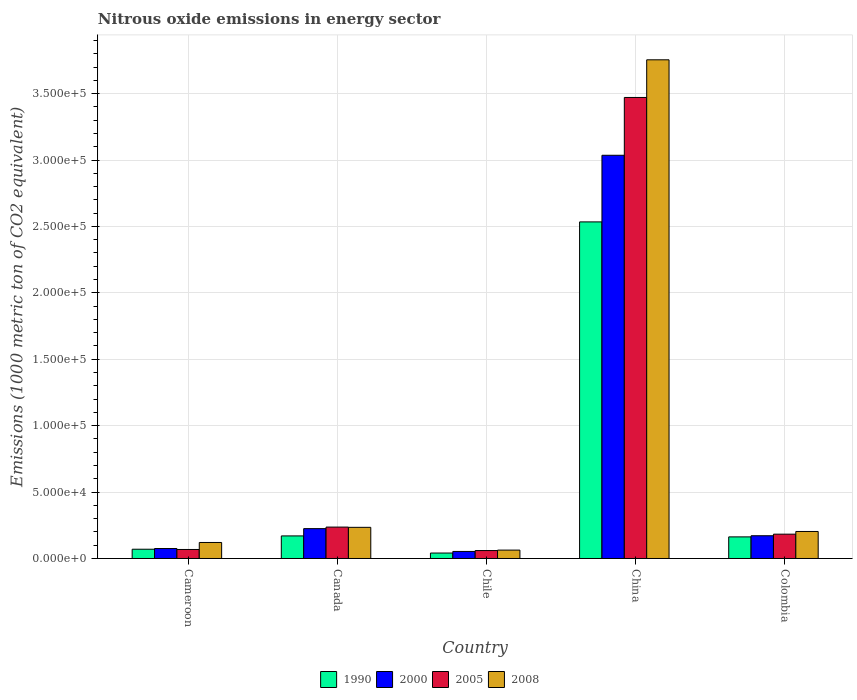How many different coloured bars are there?
Your answer should be very brief. 4. How many bars are there on the 2nd tick from the left?
Provide a succinct answer. 4. In how many cases, is the number of bars for a given country not equal to the number of legend labels?
Make the answer very short. 0. What is the amount of nitrous oxide emitted in 2008 in Cameroon?
Keep it short and to the point. 1.21e+04. Across all countries, what is the maximum amount of nitrous oxide emitted in 1990?
Your response must be concise. 2.53e+05. Across all countries, what is the minimum amount of nitrous oxide emitted in 1990?
Give a very brief answer. 4097. In which country was the amount of nitrous oxide emitted in 2005 maximum?
Ensure brevity in your answer.  China. In which country was the amount of nitrous oxide emitted in 2005 minimum?
Ensure brevity in your answer.  Chile. What is the total amount of nitrous oxide emitted in 1990 in the graph?
Ensure brevity in your answer.  2.98e+05. What is the difference between the amount of nitrous oxide emitted in 2005 in Cameroon and that in Canada?
Offer a very short reply. -1.69e+04. What is the difference between the amount of nitrous oxide emitted in 2005 in Chile and the amount of nitrous oxide emitted in 2008 in China?
Make the answer very short. -3.69e+05. What is the average amount of nitrous oxide emitted in 2008 per country?
Your response must be concise. 8.75e+04. What is the difference between the amount of nitrous oxide emitted of/in 2005 and amount of nitrous oxide emitted of/in 2000 in China?
Your response must be concise. 4.35e+04. In how many countries, is the amount of nitrous oxide emitted in 1990 greater than 140000 1000 metric ton?
Ensure brevity in your answer.  1. What is the ratio of the amount of nitrous oxide emitted in 1990 in China to that in Colombia?
Provide a succinct answer. 15.58. Is the amount of nitrous oxide emitted in 2005 in Chile less than that in Colombia?
Offer a very short reply. Yes. What is the difference between the highest and the second highest amount of nitrous oxide emitted in 1990?
Offer a very short reply. 2.37e+05. What is the difference between the highest and the lowest amount of nitrous oxide emitted in 2008?
Your response must be concise. 3.69e+05. In how many countries, is the amount of nitrous oxide emitted in 2000 greater than the average amount of nitrous oxide emitted in 2000 taken over all countries?
Offer a terse response. 1. What does the 3rd bar from the left in Chile represents?
Ensure brevity in your answer.  2005. Is it the case that in every country, the sum of the amount of nitrous oxide emitted in 2000 and amount of nitrous oxide emitted in 2005 is greater than the amount of nitrous oxide emitted in 1990?
Ensure brevity in your answer.  Yes. Are all the bars in the graph horizontal?
Offer a very short reply. No. What is the difference between two consecutive major ticks on the Y-axis?
Keep it short and to the point. 5.00e+04. Does the graph contain any zero values?
Your response must be concise. No. Does the graph contain grids?
Provide a succinct answer. Yes. How many legend labels are there?
Your answer should be compact. 4. How are the legend labels stacked?
Keep it short and to the point. Horizontal. What is the title of the graph?
Provide a short and direct response. Nitrous oxide emissions in energy sector. What is the label or title of the Y-axis?
Provide a short and direct response. Emissions (1000 metric ton of CO2 equivalent). What is the Emissions (1000 metric ton of CO2 equivalent) of 1990 in Cameroon?
Offer a very short reply. 6970.1. What is the Emissions (1000 metric ton of CO2 equivalent) of 2000 in Cameroon?
Provide a succinct answer. 7501.6. What is the Emissions (1000 metric ton of CO2 equivalent) in 2005 in Cameroon?
Give a very brief answer. 6781.9. What is the Emissions (1000 metric ton of CO2 equivalent) in 2008 in Cameroon?
Your response must be concise. 1.21e+04. What is the Emissions (1000 metric ton of CO2 equivalent) in 1990 in Canada?
Keep it short and to the point. 1.70e+04. What is the Emissions (1000 metric ton of CO2 equivalent) in 2000 in Canada?
Your response must be concise. 2.25e+04. What is the Emissions (1000 metric ton of CO2 equivalent) in 2005 in Canada?
Keep it short and to the point. 2.36e+04. What is the Emissions (1000 metric ton of CO2 equivalent) in 2008 in Canada?
Your answer should be compact. 2.34e+04. What is the Emissions (1000 metric ton of CO2 equivalent) of 1990 in Chile?
Your answer should be compact. 4097. What is the Emissions (1000 metric ton of CO2 equivalent) in 2000 in Chile?
Your answer should be very brief. 5305.7. What is the Emissions (1000 metric ton of CO2 equivalent) in 2005 in Chile?
Keep it short and to the point. 5967.8. What is the Emissions (1000 metric ton of CO2 equivalent) in 2008 in Chile?
Ensure brevity in your answer.  6312. What is the Emissions (1000 metric ton of CO2 equivalent) of 1990 in China?
Keep it short and to the point. 2.53e+05. What is the Emissions (1000 metric ton of CO2 equivalent) of 2000 in China?
Make the answer very short. 3.04e+05. What is the Emissions (1000 metric ton of CO2 equivalent) of 2005 in China?
Provide a succinct answer. 3.47e+05. What is the Emissions (1000 metric ton of CO2 equivalent) of 2008 in China?
Offer a very short reply. 3.75e+05. What is the Emissions (1000 metric ton of CO2 equivalent) of 1990 in Colombia?
Make the answer very short. 1.63e+04. What is the Emissions (1000 metric ton of CO2 equivalent) of 2000 in Colombia?
Make the answer very short. 1.71e+04. What is the Emissions (1000 metric ton of CO2 equivalent) of 2005 in Colombia?
Keep it short and to the point. 1.83e+04. What is the Emissions (1000 metric ton of CO2 equivalent) of 2008 in Colombia?
Your response must be concise. 2.03e+04. Across all countries, what is the maximum Emissions (1000 metric ton of CO2 equivalent) in 1990?
Offer a very short reply. 2.53e+05. Across all countries, what is the maximum Emissions (1000 metric ton of CO2 equivalent) of 2000?
Make the answer very short. 3.04e+05. Across all countries, what is the maximum Emissions (1000 metric ton of CO2 equivalent) of 2005?
Ensure brevity in your answer.  3.47e+05. Across all countries, what is the maximum Emissions (1000 metric ton of CO2 equivalent) in 2008?
Provide a short and direct response. 3.75e+05. Across all countries, what is the minimum Emissions (1000 metric ton of CO2 equivalent) in 1990?
Provide a succinct answer. 4097. Across all countries, what is the minimum Emissions (1000 metric ton of CO2 equivalent) of 2000?
Provide a succinct answer. 5305.7. Across all countries, what is the minimum Emissions (1000 metric ton of CO2 equivalent) in 2005?
Your answer should be very brief. 5967.8. Across all countries, what is the minimum Emissions (1000 metric ton of CO2 equivalent) of 2008?
Make the answer very short. 6312. What is the total Emissions (1000 metric ton of CO2 equivalent) in 1990 in the graph?
Make the answer very short. 2.98e+05. What is the total Emissions (1000 metric ton of CO2 equivalent) in 2000 in the graph?
Your response must be concise. 3.56e+05. What is the total Emissions (1000 metric ton of CO2 equivalent) of 2005 in the graph?
Your answer should be compact. 4.02e+05. What is the total Emissions (1000 metric ton of CO2 equivalent) in 2008 in the graph?
Give a very brief answer. 4.38e+05. What is the difference between the Emissions (1000 metric ton of CO2 equivalent) in 1990 in Cameroon and that in Canada?
Keep it short and to the point. -1.00e+04. What is the difference between the Emissions (1000 metric ton of CO2 equivalent) of 2000 in Cameroon and that in Canada?
Ensure brevity in your answer.  -1.50e+04. What is the difference between the Emissions (1000 metric ton of CO2 equivalent) in 2005 in Cameroon and that in Canada?
Offer a terse response. -1.69e+04. What is the difference between the Emissions (1000 metric ton of CO2 equivalent) of 2008 in Cameroon and that in Canada?
Offer a very short reply. -1.14e+04. What is the difference between the Emissions (1000 metric ton of CO2 equivalent) of 1990 in Cameroon and that in Chile?
Provide a succinct answer. 2873.1. What is the difference between the Emissions (1000 metric ton of CO2 equivalent) in 2000 in Cameroon and that in Chile?
Your answer should be very brief. 2195.9. What is the difference between the Emissions (1000 metric ton of CO2 equivalent) of 2005 in Cameroon and that in Chile?
Keep it short and to the point. 814.1. What is the difference between the Emissions (1000 metric ton of CO2 equivalent) in 2008 in Cameroon and that in Chile?
Offer a very short reply. 5740.9. What is the difference between the Emissions (1000 metric ton of CO2 equivalent) of 1990 in Cameroon and that in China?
Keep it short and to the point. -2.46e+05. What is the difference between the Emissions (1000 metric ton of CO2 equivalent) in 2000 in Cameroon and that in China?
Your answer should be compact. -2.96e+05. What is the difference between the Emissions (1000 metric ton of CO2 equivalent) of 2005 in Cameroon and that in China?
Provide a succinct answer. -3.40e+05. What is the difference between the Emissions (1000 metric ton of CO2 equivalent) in 2008 in Cameroon and that in China?
Your response must be concise. -3.63e+05. What is the difference between the Emissions (1000 metric ton of CO2 equivalent) of 1990 in Cameroon and that in Colombia?
Provide a succinct answer. -9292. What is the difference between the Emissions (1000 metric ton of CO2 equivalent) in 2000 in Cameroon and that in Colombia?
Ensure brevity in your answer.  -9624.9. What is the difference between the Emissions (1000 metric ton of CO2 equivalent) in 2005 in Cameroon and that in Colombia?
Offer a terse response. -1.15e+04. What is the difference between the Emissions (1000 metric ton of CO2 equivalent) in 2008 in Cameroon and that in Colombia?
Make the answer very short. -8286.7. What is the difference between the Emissions (1000 metric ton of CO2 equivalent) in 1990 in Canada and that in Chile?
Provide a succinct answer. 1.29e+04. What is the difference between the Emissions (1000 metric ton of CO2 equivalent) of 2000 in Canada and that in Chile?
Offer a very short reply. 1.72e+04. What is the difference between the Emissions (1000 metric ton of CO2 equivalent) of 2005 in Canada and that in Chile?
Ensure brevity in your answer.  1.77e+04. What is the difference between the Emissions (1000 metric ton of CO2 equivalent) in 2008 in Canada and that in Chile?
Your response must be concise. 1.71e+04. What is the difference between the Emissions (1000 metric ton of CO2 equivalent) of 1990 in Canada and that in China?
Offer a very short reply. -2.36e+05. What is the difference between the Emissions (1000 metric ton of CO2 equivalent) in 2000 in Canada and that in China?
Your response must be concise. -2.81e+05. What is the difference between the Emissions (1000 metric ton of CO2 equivalent) in 2005 in Canada and that in China?
Offer a terse response. -3.23e+05. What is the difference between the Emissions (1000 metric ton of CO2 equivalent) in 2008 in Canada and that in China?
Your answer should be very brief. -3.52e+05. What is the difference between the Emissions (1000 metric ton of CO2 equivalent) of 1990 in Canada and that in Colombia?
Your answer should be very brief. 737.3. What is the difference between the Emissions (1000 metric ton of CO2 equivalent) in 2000 in Canada and that in Colombia?
Provide a short and direct response. 5354.3. What is the difference between the Emissions (1000 metric ton of CO2 equivalent) of 2005 in Canada and that in Colombia?
Offer a very short reply. 5332.3. What is the difference between the Emissions (1000 metric ton of CO2 equivalent) in 2008 in Canada and that in Colombia?
Make the answer very short. 3108.7. What is the difference between the Emissions (1000 metric ton of CO2 equivalent) in 1990 in Chile and that in China?
Make the answer very short. -2.49e+05. What is the difference between the Emissions (1000 metric ton of CO2 equivalent) of 2000 in Chile and that in China?
Provide a short and direct response. -2.98e+05. What is the difference between the Emissions (1000 metric ton of CO2 equivalent) in 2005 in Chile and that in China?
Ensure brevity in your answer.  -3.41e+05. What is the difference between the Emissions (1000 metric ton of CO2 equivalent) of 2008 in Chile and that in China?
Give a very brief answer. -3.69e+05. What is the difference between the Emissions (1000 metric ton of CO2 equivalent) of 1990 in Chile and that in Colombia?
Offer a terse response. -1.22e+04. What is the difference between the Emissions (1000 metric ton of CO2 equivalent) in 2000 in Chile and that in Colombia?
Give a very brief answer. -1.18e+04. What is the difference between the Emissions (1000 metric ton of CO2 equivalent) of 2005 in Chile and that in Colombia?
Give a very brief answer. -1.23e+04. What is the difference between the Emissions (1000 metric ton of CO2 equivalent) of 2008 in Chile and that in Colombia?
Your answer should be very brief. -1.40e+04. What is the difference between the Emissions (1000 metric ton of CO2 equivalent) in 1990 in China and that in Colombia?
Your response must be concise. 2.37e+05. What is the difference between the Emissions (1000 metric ton of CO2 equivalent) in 2000 in China and that in Colombia?
Your response must be concise. 2.86e+05. What is the difference between the Emissions (1000 metric ton of CO2 equivalent) in 2005 in China and that in Colombia?
Give a very brief answer. 3.29e+05. What is the difference between the Emissions (1000 metric ton of CO2 equivalent) of 2008 in China and that in Colombia?
Keep it short and to the point. 3.55e+05. What is the difference between the Emissions (1000 metric ton of CO2 equivalent) of 1990 in Cameroon and the Emissions (1000 metric ton of CO2 equivalent) of 2000 in Canada?
Keep it short and to the point. -1.55e+04. What is the difference between the Emissions (1000 metric ton of CO2 equivalent) of 1990 in Cameroon and the Emissions (1000 metric ton of CO2 equivalent) of 2005 in Canada?
Your answer should be compact. -1.67e+04. What is the difference between the Emissions (1000 metric ton of CO2 equivalent) in 1990 in Cameroon and the Emissions (1000 metric ton of CO2 equivalent) in 2008 in Canada?
Offer a very short reply. -1.65e+04. What is the difference between the Emissions (1000 metric ton of CO2 equivalent) in 2000 in Cameroon and the Emissions (1000 metric ton of CO2 equivalent) in 2005 in Canada?
Ensure brevity in your answer.  -1.61e+04. What is the difference between the Emissions (1000 metric ton of CO2 equivalent) of 2000 in Cameroon and the Emissions (1000 metric ton of CO2 equivalent) of 2008 in Canada?
Keep it short and to the point. -1.59e+04. What is the difference between the Emissions (1000 metric ton of CO2 equivalent) of 2005 in Cameroon and the Emissions (1000 metric ton of CO2 equivalent) of 2008 in Canada?
Provide a short and direct response. -1.67e+04. What is the difference between the Emissions (1000 metric ton of CO2 equivalent) of 1990 in Cameroon and the Emissions (1000 metric ton of CO2 equivalent) of 2000 in Chile?
Provide a short and direct response. 1664.4. What is the difference between the Emissions (1000 metric ton of CO2 equivalent) in 1990 in Cameroon and the Emissions (1000 metric ton of CO2 equivalent) in 2005 in Chile?
Ensure brevity in your answer.  1002.3. What is the difference between the Emissions (1000 metric ton of CO2 equivalent) of 1990 in Cameroon and the Emissions (1000 metric ton of CO2 equivalent) of 2008 in Chile?
Offer a very short reply. 658.1. What is the difference between the Emissions (1000 metric ton of CO2 equivalent) of 2000 in Cameroon and the Emissions (1000 metric ton of CO2 equivalent) of 2005 in Chile?
Give a very brief answer. 1533.8. What is the difference between the Emissions (1000 metric ton of CO2 equivalent) of 2000 in Cameroon and the Emissions (1000 metric ton of CO2 equivalent) of 2008 in Chile?
Make the answer very short. 1189.6. What is the difference between the Emissions (1000 metric ton of CO2 equivalent) in 2005 in Cameroon and the Emissions (1000 metric ton of CO2 equivalent) in 2008 in Chile?
Keep it short and to the point. 469.9. What is the difference between the Emissions (1000 metric ton of CO2 equivalent) of 1990 in Cameroon and the Emissions (1000 metric ton of CO2 equivalent) of 2000 in China?
Offer a very short reply. -2.97e+05. What is the difference between the Emissions (1000 metric ton of CO2 equivalent) in 1990 in Cameroon and the Emissions (1000 metric ton of CO2 equivalent) in 2005 in China?
Provide a succinct answer. -3.40e+05. What is the difference between the Emissions (1000 metric ton of CO2 equivalent) in 1990 in Cameroon and the Emissions (1000 metric ton of CO2 equivalent) in 2008 in China?
Give a very brief answer. -3.68e+05. What is the difference between the Emissions (1000 metric ton of CO2 equivalent) in 2000 in Cameroon and the Emissions (1000 metric ton of CO2 equivalent) in 2005 in China?
Give a very brief answer. -3.40e+05. What is the difference between the Emissions (1000 metric ton of CO2 equivalent) of 2000 in Cameroon and the Emissions (1000 metric ton of CO2 equivalent) of 2008 in China?
Give a very brief answer. -3.68e+05. What is the difference between the Emissions (1000 metric ton of CO2 equivalent) of 2005 in Cameroon and the Emissions (1000 metric ton of CO2 equivalent) of 2008 in China?
Provide a short and direct response. -3.69e+05. What is the difference between the Emissions (1000 metric ton of CO2 equivalent) in 1990 in Cameroon and the Emissions (1000 metric ton of CO2 equivalent) in 2000 in Colombia?
Your answer should be compact. -1.02e+04. What is the difference between the Emissions (1000 metric ton of CO2 equivalent) of 1990 in Cameroon and the Emissions (1000 metric ton of CO2 equivalent) of 2005 in Colombia?
Provide a short and direct response. -1.13e+04. What is the difference between the Emissions (1000 metric ton of CO2 equivalent) in 1990 in Cameroon and the Emissions (1000 metric ton of CO2 equivalent) in 2008 in Colombia?
Offer a terse response. -1.34e+04. What is the difference between the Emissions (1000 metric ton of CO2 equivalent) in 2000 in Cameroon and the Emissions (1000 metric ton of CO2 equivalent) in 2005 in Colombia?
Provide a succinct answer. -1.08e+04. What is the difference between the Emissions (1000 metric ton of CO2 equivalent) in 2000 in Cameroon and the Emissions (1000 metric ton of CO2 equivalent) in 2008 in Colombia?
Your response must be concise. -1.28e+04. What is the difference between the Emissions (1000 metric ton of CO2 equivalent) of 2005 in Cameroon and the Emissions (1000 metric ton of CO2 equivalent) of 2008 in Colombia?
Your response must be concise. -1.36e+04. What is the difference between the Emissions (1000 metric ton of CO2 equivalent) in 1990 in Canada and the Emissions (1000 metric ton of CO2 equivalent) in 2000 in Chile?
Keep it short and to the point. 1.17e+04. What is the difference between the Emissions (1000 metric ton of CO2 equivalent) of 1990 in Canada and the Emissions (1000 metric ton of CO2 equivalent) of 2005 in Chile?
Ensure brevity in your answer.  1.10e+04. What is the difference between the Emissions (1000 metric ton of CO2 equivalent) of 1990 in Canada and the Emissions (1000 metric ton of CO2 equivalent) of 2008 in Chile?
Make the answer very short. 1.07e+04. What is the difference between the Emissions (1000 metric ton of CO2 equivalent) of 2000 in Canada and the Emissions (1000 metric ton of CO2 equivalent) of 2005 in Chile?
Give a very brief answer. 1.65e+04. What is the difference between the Emissions (1000 metric ton of CO2 equivalent) of 2000 in Canada and the Emissions (1000 metric ton of CO2 equivalent) of 2008 in Chile?
Your answer should be compact. 1.62e+04. What is the difference between the Emissions (1000 metric ton of CO2 equivalent) of 2005 in Canada and the Emissions (1000 metric ton of CO2 equivalent) of 2008 in Chile?
Keep it short and to the point. 1.73e+04. What is the difference between the Emissions (1000 metric ton of CO2 equivalent) in 1990 in Canada and the Emissions (1000 metric ton of CO2 equivalent) in 2000 in China?
Your answer should be compact. -2.87e+05. What is the difference between the Emissions (1000 metric ton of CO2 equivalent) in 1990 in Canada and the Emissions (1000 metric ton of CO2 equivalent) in 2005 in China?
Offer a terse response. -3.30e+05. What is the difference between the Emissions (1000 metric ton of CO2 equivalent) of 1990 in Canada and the Emissions (1000 metric ton of CO2 equivalent) of 2008 in China?
Make the answer very short. -3.58e+05. What is the difference between the Emissions (1000 metric ton of CO2 equivalent) of 2000 in Canada and the Emissions (1000 metric ton of CO2 equivalent) of 2005 in China?
Give a very brief answer. -3.25e+05. What is the difference between the Emissions (1000 metric ton of CO2 equivalent) in 2000 in Canada and the Emissions (1000 metric ton of CO2 equivalent) in 2008 in China?
Keep it short and to the point. -3.53e+05. What is the difference between the Emissions (1000 metric ton of CO2 equivalent) of 2005 in Canada and the Emissions (1000 metric ton of CO2 equivalent) of 2008 in China?
Offer a very short reply. -3.52e+05. What is the difference between the Emissions (1000 metric ton of CO2 equivalent) in 1990 in Canada and the Emissions (1000 metric ton of CO2 equivalent) in 2000 in Colombia?
Ensure brevity in your answer.  -127.1. What is the difference between the Emissions (1000 metric ton of CO2 equivalent) of 1990 in Canada and the Emissions (1000 metric ton of CO2 equivalent) of 2005 in Colombia?
Offer a terse response. -1310.3. What is the difference between the Emissions (1000 metric ton of CO2 equivalent) of 1990 in Canada and the Emissions (1000 metric ton of CO2 equivalent) of 2008 in Colombia?
Ensure brevity in your answer.  -3340.2. What is the difference between the Emissions (1000 metric ton of CO2 equivalent) in 2000 in Canada and the Emissions (1000 metric ton of CO2 equivalent) in 2005 in Colombia?
Your answer should be very brief. 4171.1. What is the difference between the Emissions (1000 metric ton of CO2 equivalent) of 2000 in Canada and the Emissions (1000 metric ton of CO2 equivalent) of 2008 in Colombia?
Offer a terse response. 2141.2. What is the difference between the Emissions (1000 metric ton of CO2 equivalent) in 2005 in Canada and the Emissions (1000 metric ton of CO2 equivalent) in 2008 in Colombia?
Keep it short and to the point. 3302.4. What is the difference between the Emissions (1000 metric ton of CO2 equivalent) in 1990 in Chile and the Emissions (1000 metric ton of CO2 equivalent) in 2000 in China?
Offer a terse response. -2.99e+05. What is the difference between the Emissions (1000 metric ton of CO2 equivalent) in 1990 in Chile and the Emissions (1000 metric ton of CO2 equivalent) in 2005 in China?
Your answer should be compact. -3.43e+05. What is the difference between the Emissions (1000 metric ton of CO2 equivalent) in 1990 in Chile and the Emissions (1000 metric ton of CO2 equivalent) in 2008 in China?
Your answer should be very brief. -3.71e+05. What is the difference between the Emissions (1000 metric ton of CO2 equivalent) in 2000 in Chile and the Emissions (1000 metric ton of CO2 equivalent) in 2005 in China?
Make the answer very short. -3.42e+05. What is the difference between the Emissions (1000 metric ton of CO2 equivalent) in 2000 in Chile and the Emissions (1000 metric ton of CO2 equivalent) in 2008 in China?
Give a very brief answer. -3.70e+05. What is the difference between the Emissions (1000 metric ton of CO2 equivalent) of 2005 in Chile and the Emissions (1000 metric ton of CO2 equivalent) of 2008 in China?
Your response must be concise. -3.69e+05. What is the difference between the Emissions (1000 metric ton of CO2 equivalent) of 1990 in Chile and the Emissions (1000 metric ton of CO2 equivalent) of 2000 in Colombia?
Your answer should be compact. -1.30e+04. What is the difference between the Emissions (1000 metric ton of CO2 equivalent) in 1990 in Chile and the Emissions (1000 metric ton of CO2 equivalent) in 2005 in Colombia?
Keep it short and to the point. -1.42e+04. What is the difference between the Emissions (1000 metric ton of CO2 equivalent) in 1990 in Chile and the Emissions (1000 metric ton of CO2 equivalent) in 2008 in Colombia?
Your answer should be very brief. -1.62e+04. What is the difference between the Emissions (1000 metric ton of CO2 equivalent) of 2000 in Chile and the Emissions (1000 metric ton of CO2 equivalent) of 2005 in Colombia?
Offer a very short reply. -1.30e+04. What is the difference between the Emissions (1000 metric ton of CO2 equivalent) of 2000 in Chile and the Emissions (1000 metric ton of CO2 equivalent) of 2008 in Colombia?
Offer a terse response. -1.50e+04. What is the difference between the Emissions (1000 metric ton of CO2 equivalent) in 2005 in Chile and the Emissions (1000 metric ton of CO2 equivalent) in 2008 in Colombia?
Provide a short and direct response. -1.44e+04. What is the difference between the Emissions (1000 metric ton of CO2 equivalent) in 1990 in China and the Emissions (1000 metric ton of CO2 equivalent) in 2000 in Colombia?
Make the answer very short. 2.36e+05. What is the difference between the Emissions (1000 metric ton of CO2 equivalent) in 1990 in China and the Emissions (1000 metric ton of CO2 equivalent) in 2005 in Colombia?
Your answer should be compact. 2.35e+05. What is the difference between the Emissions (1000 metric ton of CO2 equivalent) of 1990 in China and the Emissions (1000 metric ton of CO2 equivalent) of 2008 in Colombia?
Keep it short and to the point. 2.33e+05. What is the difference between the Emissions (1000 metric ton of CO2 equivalent) of 2000 in China and the Emissions (1000 metric ton of CO2 equivalent) of 2005 in Colombia?
Ensure brevity in your answer.  2.85e+05. What is the difference between the Emissions (1000 metric ton of CO2 equivalent) in 2000 in China and the Emissions (1000 metric ton of CO2 equivalent) in 2008 in Colombia?
Provide a succinct answer. 2.83e+05. What is the difference between the Emissions (1000 metric ton of CO2 equivalent) of 2005 in China and the Emissions (1000 metric ton of CO2 equivalent) of 2008 in Colombia?
Offer a very short reply. 3.27e+05. What is the average Emissions (1000 metric ton of CO2 equivalent) of 1990 per country?
Offer a terse response. 5.95e+04. What is the average Emissions (1000 metric ton of CO2 equivalent) of 2000 per country?
Offer a very short reply. 7.12e+04. What is the average Emissions (1000 metric ton of CO2 equivalent) in 2005 per country?
Your answer should be compact. 8.04e+04. What is the average Emissions (1000 metric ton of CO2 equivalent) in 2008 per country?
Ensure brevity in your answer.  8.75e+04. What is the difference between the Emissions (1000 metric ton of CO2 equivalent) of 1990 and Emissions (1000 metric ton of CO2 equivalent) of 2000 in Cameroon?
Your response must be concise. -531.5. What is the difference between the Emissions (1000 metric ton of CO2 equivalent) in 1990 and Emissions (1000 metric ton of CO2 equivalent) in 2005 in Cameroon?
Ensure brevity in your answer.  188.2. What is the difference between the Emissions (1000 metric ton of CO2 equivalent) in 1990 and Emissions (1000 metric ton of CO2 equivalent) in 2008 in Cameroon?
Give a very brief answer. -5082.8. What is the difference between the Emissions (1000 metric ton of CO2 equivalent) in 2000 and Emissions (1000 metric ton of CO2 equivalent) in 2005 in Cameroon?
Give a very brief answer. 719.7. What is the difference between the Emissions (1000 metric ton of CO2 equivalent) in 2000 and Emissions (1000 metric ton of CO2 equivalent) in 2008 in Cameroon?
Your answer should be compact. -4551.3. What is the difference between the Emissions (1000 metric ton of CO2 equivalent) in 2005 and Emissions (1000 metric ton of CO2 equivalent) in 2008 in Cameroon?
Your response must be concise. -5271. What is the difference between the Emissions (1000 metric ton of CO2 equivalent) in 1990 and Emissions (1000 metric ton of CO2 equivalent) in 2000 in Canada?
Offer a terse response. -5481.4. What is the difference between the Emissions (1000 metric ton of CO2 equivalent) in 1990 and Emissions (1000 metric ton of CO2 equivalent) in 2005 in Canada?
Your response must be concise. -6642.6. What is the difference between the Emissions (1000 metric ton of CO2 equivalent) in 1990 and Emissions (1000 metric ton of CO2 equivalent) in 2008 in Canada?
Give a very brief answer. -6448.9. What is the difference between the Emissions (1000 metric ton of CO2 equivalent) of 2000 and Emissions (1000 metric ton of CO2 equivalent) of 2005 in Canada?
Keep it short and to the point. -1161.2. What is the difference between the Emissions (1000 metric ton of CO2 equivalent) in 2000 and Emissions (1000 metric ton of CO2 equivalent) in 2008 in Canada?
Give a very brief answer. -967.5. What is the difference between the Emissions (1000 metric ton of CO2 equivalent) in 2005 and Emissions (1000 metric ton of CO2 equivalent) in 2008 in Canada?
Provide a short and direct response. 193.7. What is the difference between the Emissions (1000 metric ton of CO2 equivalent) of 1990 and Emissions (1000 metric ton of CO2 equivalent) of 2000 in Chile?
Provide a short and direct response. -1208.7. What is the difference between the Emissions (1000 metric ton of CO2 equivalent) of 1990 and Emissions (1000 metric ton of CO2 equivalent) of 2005 in Chile?
Provide a short and direct response. -1870.8. What is the difference between the Emissions (1000 metric ton of CO2 equivalent) in 1990 and Emissions (1000 metric ton of CO2 equivalent) in 2008 in Chile?
Provide a succinct answer. -2215. What is the difference between the Emissions (1000 metric ton of CO2 equivalent) in 2000 and Emissions (1000 metric ton of CO2 equivalent) in 2005 in Chile?
Your response must be concise. -662.1. What is the difference between the Emissions (1000 metric ton of CO2 equivalent) in 2000 and Emissions (1000 metric ton of CO2 equivalent) in 2008 in Chile?
Make the answer very short. -1006.3. What is the difference between the Emissions (1000 metric ton of CO2 equivalent) of 2005 and Emissions (1000 metric ton of CO2 equivalent) of 2008 in Chile?
Keep it short and to the point. -344.2. What is the difference between the Emissions (1000 metric ton of CO2 equivalent) in 1990 and Emissions (1000 metric ton of CO2 equivalent) in 2000 in China?
Provide a short and direct response. -5.02e+04. What is the difference between the Emissions (1000 metric ton of CO2 equivalent) in 1990 and Emissions (1000 metric ton of CO2 equivalent) in 2005 in China?
Make the answer very short. -9.37e+04. What is the difference between the Emissions (1000 metric ton of CO2 equivalent) in 1990 and Emissions (1000 metric ton of CO2 equivalent) in 2008 in China?
Your response must be concise. -1.22e+05. What is the difference between the Emissions (1000 metric ton of CO2 equivalent) of 2000 and Emissions (1000 metric ton of CO2 equivalent) of 2005 in China?
Your response must be concise. -4.35e+04. What is the difference between the Emissions (1000 metric ton of CO2 equivalent) in 2000 and Emissions (1000 metric ton of CO2 equivalent) in 2008 in China?
Provide a short and direct response. -7.19e+04. What is the difference between the Emissions (1000 metric ton of CO2 equivalent) in 2005 and Emissions (1000 metric ton of CO2 equivalent) in 2008 in China?
Offer a very short reply. -2.83e+04. What is the difference between the Emissions (1000 metric ton of CO2 equivalent) of 1990 and Emissions (1000 metric ton of CO2 equivalent) of 2000 in Colombia?
Make the answer very short. -864.4. What is the difference between the Emissions (1000 metric ton of CO2 equivalent) of 1990 and Emissions (1000 metric ton of CO2 equivalent) of 2005 in Colombia?
Keep it short and to the point. -2047.6. What is the difference between the Emissions (1000 metric ton of CO2 equivalent) in 1990 and Emissions (1000 metric ton of CO2 equivalent) in 2008 in Colombia?
Give a very brief answer. -4077.5. What is the difference between the Emissions (1000 metric ton of CO2 equivalent) of 2000 and Emissions (1000 metric ton of CO2 equivalent) of 2005 in Colombia?
Offer a terse response. -1183.2. What is the difference between the Emissions (1000 metric ton of CO2 equivalent) in 2000 and Emissions (1000 metric ton of CO2 equivalent) in 2008 in Colombia?
Offer a very short reply. -3213.1. What is the difference between the Emissions (1000 metric ton of CO2 equivalent) of 2005 and Emissions (1000 metric ton of CO2 equivalent) of 2008 in Colombia?
Give a very brief answer. -2029.9. What is the ratio of the Emissions (1000 metric ton of CO2 equivalent) of 1990 in Cameroon to that in Canada?
Your answer should be very brief. 0.41. What is the ratio of the Emissions (1000 metric ton of CO2 equivalent) of 2000 in Cameroon to that in Canada?
Your answer should be very brief. 0.33. What is the ratio of the Emissions (1000 metric ton of CO2 equivalent) of 2005 in Cameroon to that in Canada?
Your answer should be very brief. 0.29. What is the ratio of the Emissions (1000 metric ton of CO2 equivalent) of 2008 in Cameroon to that in Canada?
Offer a very short reply. 0.51. What is the ratio of the Emissions (1000 metric ton of CO2 equivalent) in 1990 in Cameroon to that in Chile?
Your answer should be very brief. 1.7. What is the ratio of the Emissions (1000 metric ton of CO2 equivalent) of 2000 in Cameroon to that in Chile?
Keep it short and to the point. 1.41. What is the ratio of the Emissions (1000 metric ton of CO2 equivalent) in 2005 in Cameroon to that in Chile?
Offer a terse response. 1.14. What is the ratio of the Emissions (1000 metric ton of CO2 equivalent) in 2008 in Cameroon to that in Chile?
Provide a succinct answer. 1.91. What is the ratio of the Emissions (1000 metric ton of CO2 equivalent) in 1990 in Cameroon to that in China?
Offer a very short reply. 0.03. What is the ratio of the Emissions (1000 metric ton of CO2 equivalent) in 2000 in Cameroon to that in China?
Offer a very short reply. 0.02. What is the ratio of the Emissions (1000 metric ton of CO2 equivalent) of 2005 in Cameroon to that in China?
Your answer should be compact. 0.02. What is the ratio of the Emissions (1000 metric ton of CO2 equivalent) of 2008 in Cameroon to that in China?
Your response must be concise. 0.03. What is the ratio of the Emissions (1000 metric ton of CO2 equivalent) in 1990 in Cameroon to that in Colombia?
Give a very brief answer. 0.43. What is the ratio of the Emissions (1000 metric ton of CO2 equivalent) of 2000 in Cameroon to that in Colombia?
Provide a short and direct response. 0.44. What is the ratio of the Emissions (1000 metric ton of CO2 equivalent) in 2005 in Cameroon to that in Colombia?
Offer a very short reply. 0.37. What is the ratio of the Emissions (1000 metric ton of CO2 equivalent) in 2008 in Cameroon to that in Colombia?
Your answer should be compact. 0.59. What is the ratio of the Emissions (1000 metric ton of CO2 equivalent) in 1990 in Canada to that in Chile?
Offer a very short reply. 4.15. What is the ratio of the Emissions (1000 metric ton of CO2 equivalent) in 2000 in Canada to that in Chile?
Offer a terse response. 4.24. What is the ratio of the Emissions (1000 metric ton of CO2 equivalent) of 2005 in Canada to that in Chile?
Your response must be concise. 3.96. What is the ratio of the Emissions (1000 metric ton of CO2 equivalent) of 2008 in Canada to that in Chile?
Offer a terse response. 3.71. What is the ratio of the Emissions (1000 metric ton of CO2 equivalent) in 1990 in Canada to that in China?
Ensure brevity in your answer.  0.07. What is the ratio of the Emissions (1000 metric ton of CO2 equivalent) in 2000 in Canada to that in China?
Your answer should be very brief. 0.07. What is the ratio of the Emissions (1000 metric ton of CO2 equivalent) in 2005 in Canada to that in China?
Your answer should be compact. 0.07. What is the ratio of the Emissions (1000 metric ton of CO2 equivalent) in 2008 in Canada to that in China?
Your response must be concise. 0.06. What is the ratio of the Emissions (1000 metric ton of CO2 equivalent) in 1990 in Canada to that in Colombia?
Ensure brevity in your answer.  1.05. What is the ratio of the Emissions (1000 metric ton of CO2 equivalent) in 2000 in Canada to that in Colombia?
Your response must be concise. 1.31. What is the ratio of the Emissions (1000 metric ton of CO2 equivalent) in 2005 in Canada to that in Colombia?
Provide a succinct answer. 1.29. What is the ratio of the Emissions (1000 metric ton of CO2 equivalent) in 2008 in Canada to that in Colombia?
Make the answer very short. 1.15. What is the ratio of the Emissions (1000 metric ton of CO2 equivalent) in 1990 in Chile to that in China?
Provide a short and direct response. 0.02. What is the ratio of the Emissions (1000 metric ton of CO2 equivalent) of 2000 in Chile to that in China?
Your answer should be very brief. 0.02. What is the ratio of the Emissions (1000 metric ton of CO2 equivalent) of 2005 in Chile to that in China?
Your response must be concise. 0.02. What is the ratio of the Emissions (1000 metric ton of CO2 equivalent) of 2008 in Chile to that in China?
Keep it short and to the point. 0.02. What is the ratio of the Emissions (1000 metric ton of CO2 equivalent) of 1990 in Chile to that in Colombia?
Your answer should be very brief. 0.25. What is the ratio of the Emissions (1000 metric ton of CO2 equivalent) in 2000 in Chile to that in Colombia?
Your answer should be compact. 0.31. What is the ratio of the Emissions (1000 metric ton of CO2 equivalent) of 2005 in Chile to that in Colombia?
Offer a terse response. 0.33. What is the ratio of the Emissions (1000 metric ton of CO2 equivalent) in 2008 in Chile to that in Colombia?
Provide a short and direct response. 0.31. What is the ratio of the Emissions (1000 metric ton of CO2 equivalent) in 1990 in China to that in Colombia?
Give a very brief answer. 15.58. What is the ratio of the Emissions (1000 metric ton of CO2 equivalent) in 2000 in China to that in Colombia?
Offer a very short reply. 17.72. What is the ratio of the Emissions (1000 metric ton of CO2 equivalent) of 2005 in China to that in Colombia?
Your answer should be very brief. 18.96. What is the ratio of the Emissions (1000 metric ton of CO2 equivalent) in 2008 in China to that in Colombia?
Make the answer very short. 18.46. What is the difference between the highest and the second highest Emissions (1000 metric ton of CO2 equivalent) of 1990?
Your answer should be very brief. 2.36e+05. What is the difference between the highest and the second highest Emissions (1000 metric ton of CO2 equivalent) of 2000?
Offer a very short reply. 2.81e+05. What is the difference between the highest and the second highest Emissions (1000 metric ton of CO2 equivalent) in 2005?
Give a very brief answer. 3.23e+05. What is the difference between the highest and the second highest Emissions (1000 metric ton of CO2 equivalent) of 2008?
Give a very brief answer. 3.52e+05. What is the difference between the highest and the lowest Emissions (1000 metric ton of CO2 equivalent) in 1990?
Offer a terse response. 2.49e+05. What is the difference between the highest and the lowest Emissions (1000 metric ton of CO2 equivalent) of 2000?
Your answer should be compact. 2.98e+05. What is the difference between the highest and the lowest Emissions (1000 metric ton of CO2 equivalent) in 2005?
Provide a short and direct response. 3.41e+05. What is the difference between the highest and the lowest Emissions (1000 metric ton of CO2 equivalent) of 2008?
Provide a succinct answer. 3.69e+05. 